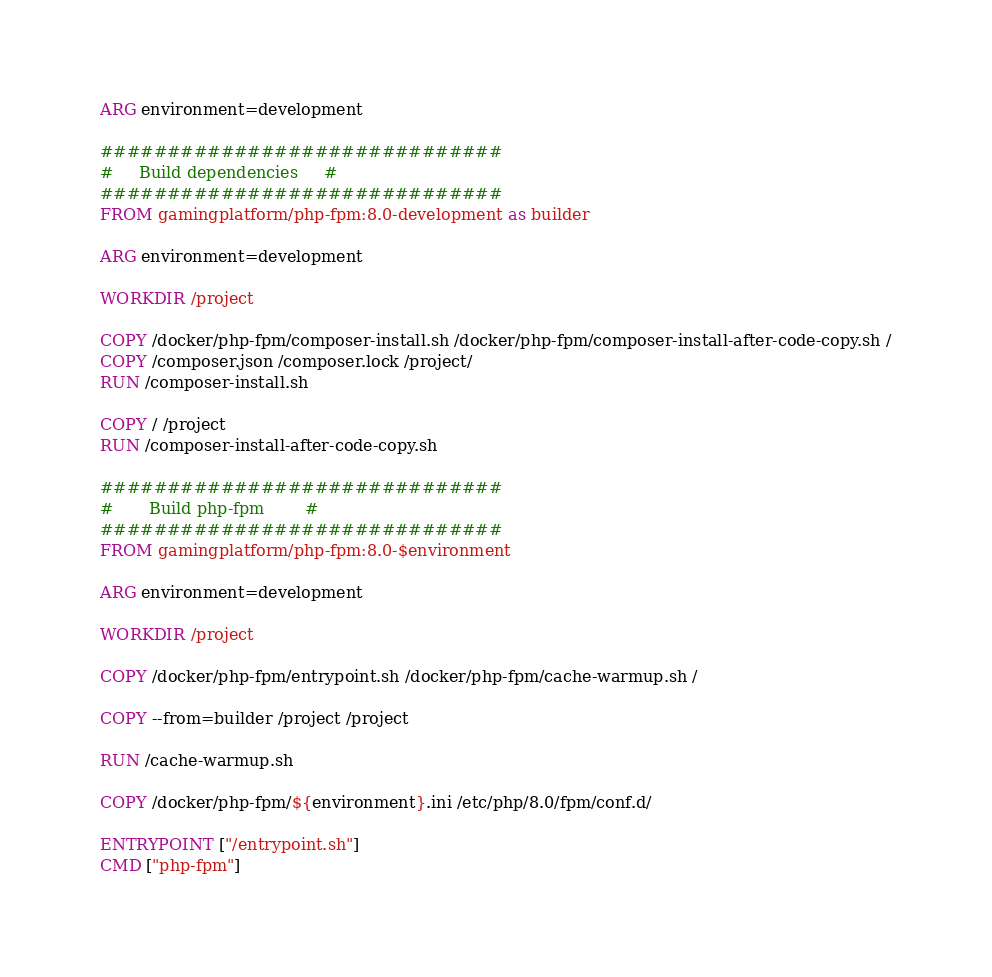Convert code to text. <code><loc_0><loc_0><loc_500><loc_500><_Dockerfile_>ARG environment=development

##############################
#     Build dependencies     #
##############################
FROM gamingplatform/php-fpm:8.0-development as builder

ARG environment=development

WORKDIR /project

COPY /docker/php-fpm/composer-install.sh /docker/php-fpm/composer-install-after-code-copy.sh /
COPY /composer.json /composer.lock /project/
RUN /composer-install.sh

COPY / /project
RUN /composer-install-after-code-copy.sh

##############################
#       Build php-fpm        #
##############################
FROM gamingplatform/php-fpm:8.0-$environment

ARG environment=development

WORKDIR /project

COPY /docker/php-fpm/entrypoint.sh /docker/php-fpm/cache-warmup.sh /

COPY --from=builder /project /project

RUN /cache-warmup.sh

COPY /docker/php-fpm/${environment}.ini /etc/php/8.0/fpm/conf.d/

ENTRYPOINT ["/entrypoint.sh"]
CMD ["php-fpm"]
</code> 